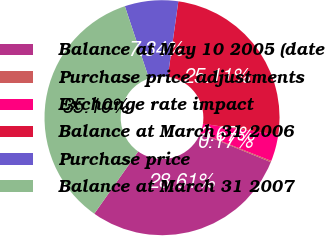<chart> <loc_0><loc_0><loc_500><loc_500><pie_chart><fcel>Balance at May 10 2005 (date<fcel>Purchase price adjustments<fcel>Exchange rate impact<fcel>Balance at March 31 2006<fcel>Purchase price<fcel>Balance at March 31 2007<nl><fcel>28.61%<fcel>0.17%<fcel>3.67%<fcel>25.11%<fcel>7.34%<fcel>35.1%<nl></chart> 